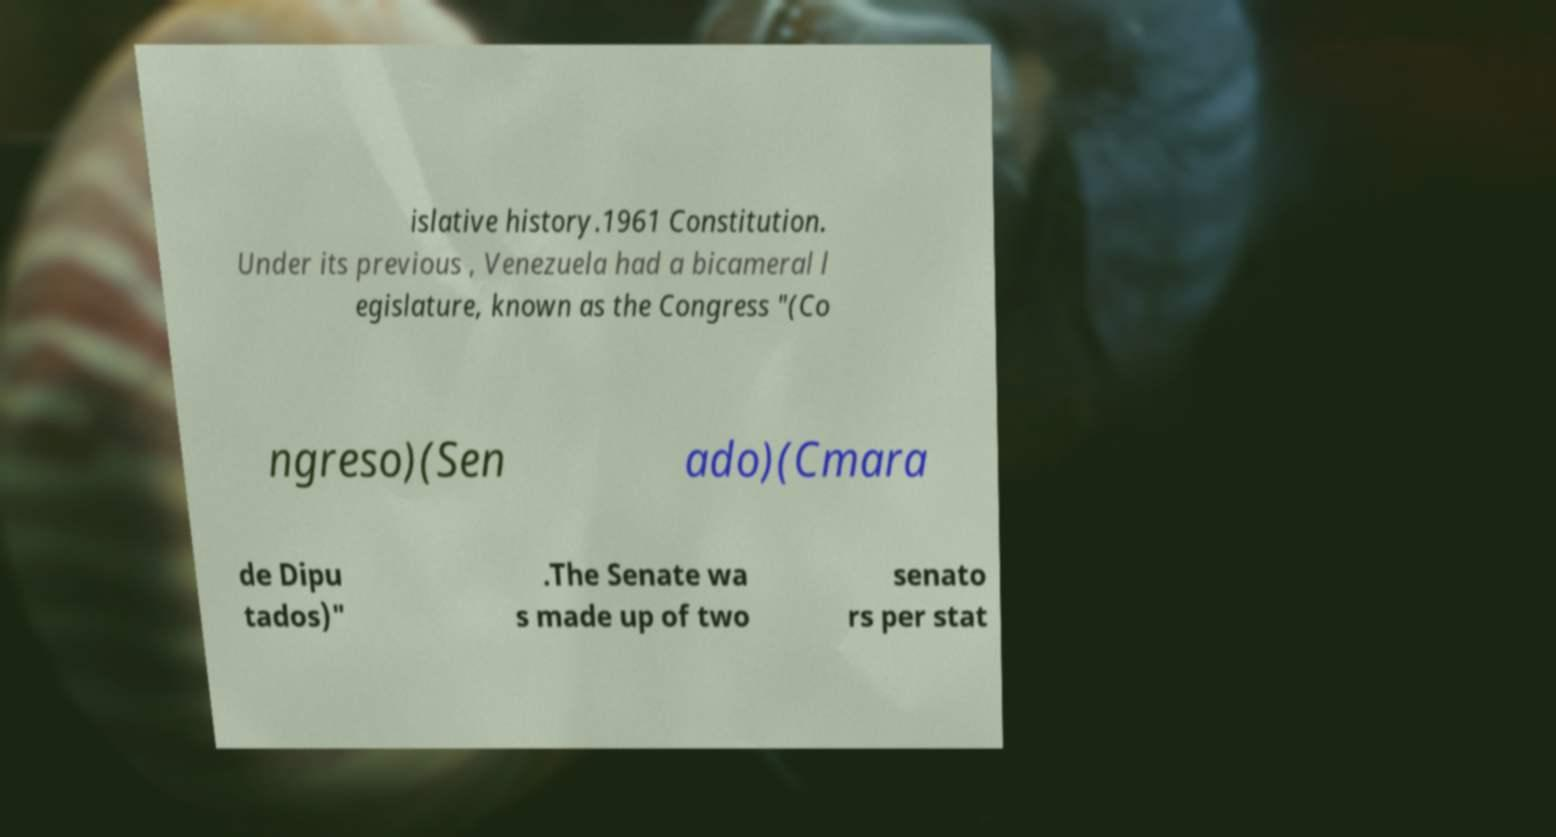Could you assist in decoding the text presented in this image and type it out clearly? islative history.1961 Constitution. Under its previous , Venezuela had a bicameral l egislature, known as the Congress "(Co ngreso)(Sen ado)(Cmara de Dipu tados)" .The Senate wa s made up of two senato rs per stat 